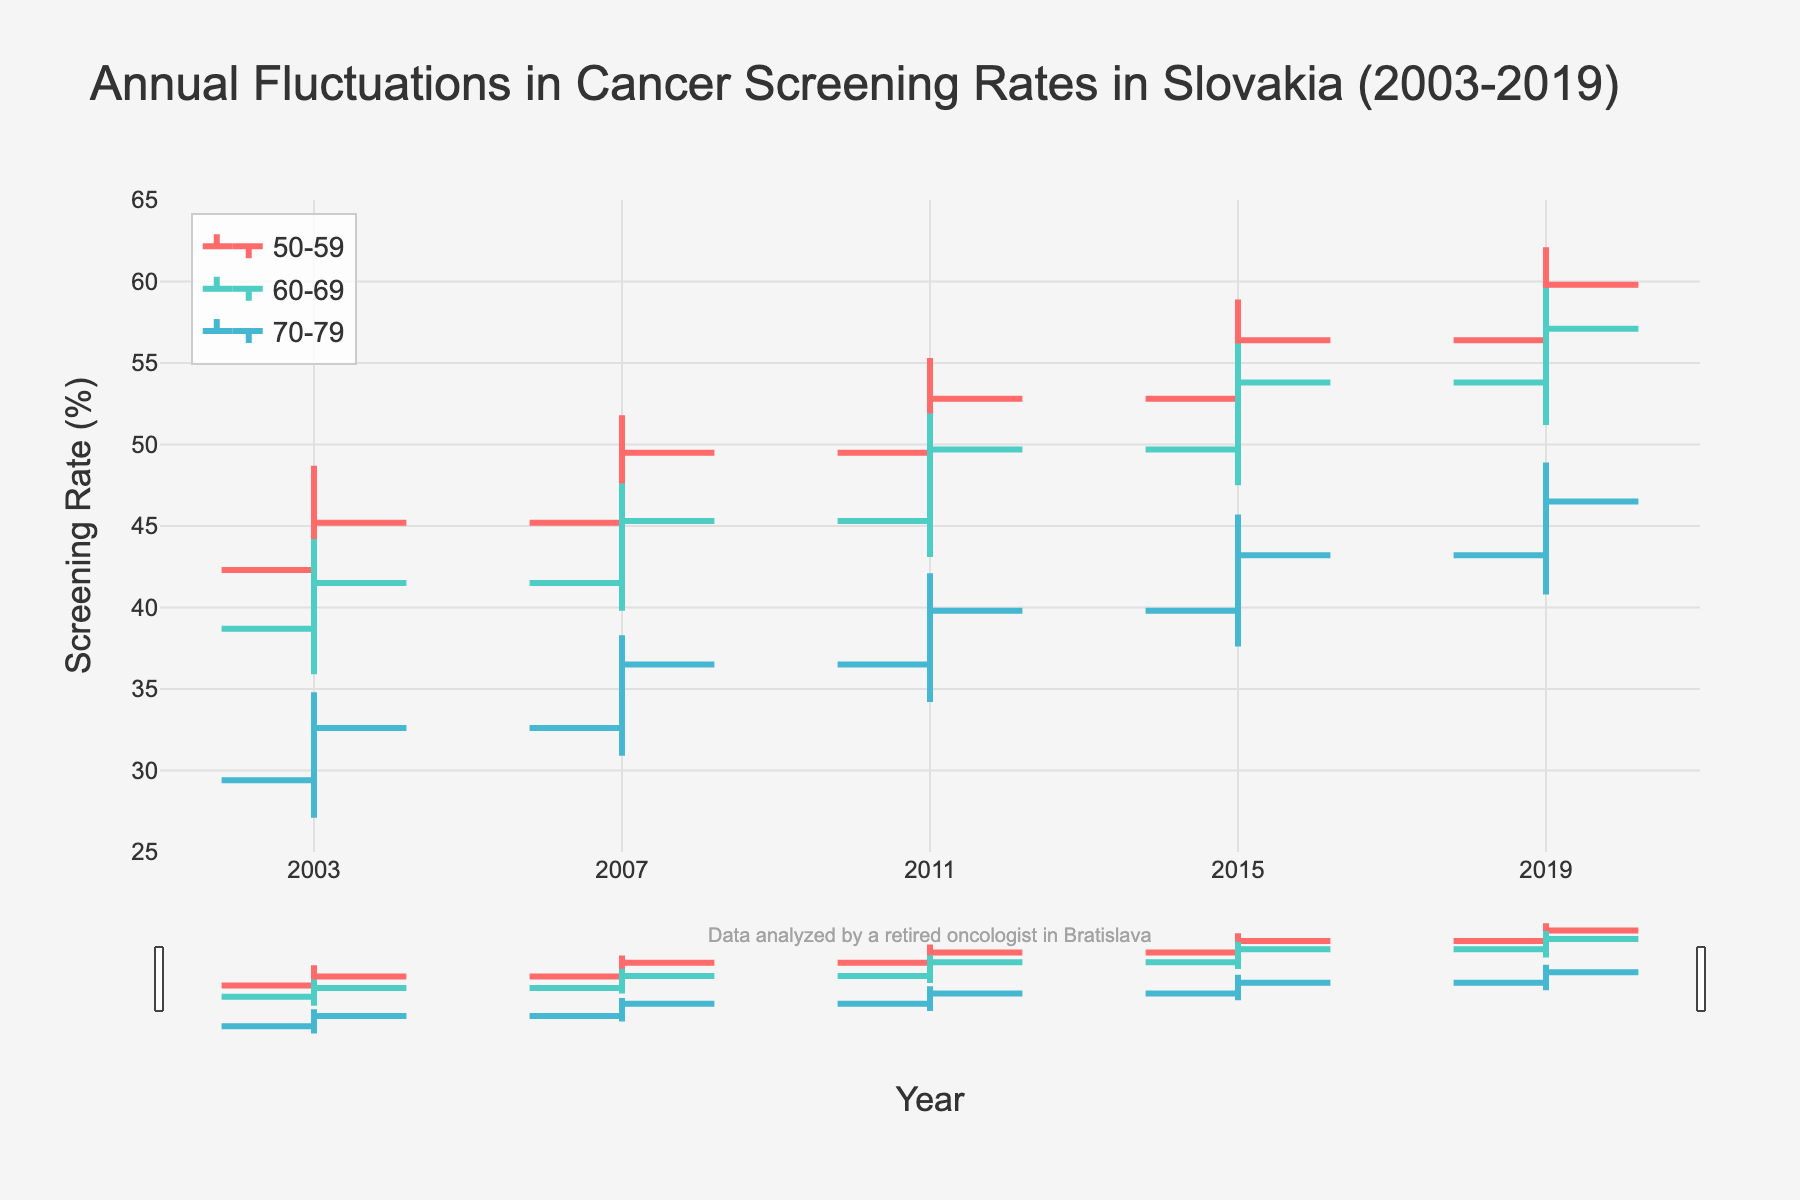What is the title of the figure? The title is located at the top of the chart and often describes what the chart portrays. Here, it reads "Annual Fluctuations in Cancer Screening Rates in Slovakia (2003-2019)."
Answer: Annual Fluctuations in Cancer Screening Rates in Slovakia (2003-2019) What is the y-axis title? The y-axis title describes what the vertical axis measures. In this chart, it indicates the percentage of screening rates.
Answer: Screening Rate (%) Which age group had the highest screening rate in 2019? To answer this, we need to identify the "High" value for all age groups in the year 2019 and pick the highest one. For 50-59, it is 62.1; for 60-69, it is 59.6; for 70-79, it is 48.9. The highest among these is 62.1 for the age group 50-59.
Answer: 50-59 What was the screening rate range for the age group 60-69 in 2003? To find the range, we need to determine the difference between "High" and "Low" values for the age group 60-69 in 2003. The "High" is 44.2 and the "Low" is 35.9. The range is 44.2 - 35.9 = 8.3.
Answer: 8.3 Between 2003 and 2019, how much did the closing screening rate increase for the age group 50-59? We subtract the closing rate in 2003 from the closing rate in 2019 for the age group 50-59. The closing rate in 2003 is 45.2, and in 2019 it is 59.8. The increase is 59.8 - 45.2 = 14.6.
Answer: 14.6 Which age group showed the smallest overall range in screening rates in 2015? We compare the ranges (High - Low) for each age group in 2015. For 50-59: 58.9 - 50.1 = 8.8; for 60-69: 56.2 - 47.5 = 8.7; for 70-79: 45.7 - 37.6 = 8.1. The smallest range is 8.1 for age group 70-79.
Answer: 70-79 Which age group had the most consistent screening rates from 2003 to 2019? Consistency can be judged by smaller ranges over time. Summing up the ranges for all years for each age group: 50-59: (48.7-39.1)+(51.8-43.6)+(55.3-47.2)+(58.9-50.1)+(62.1-54.7) = 9.6+8.2+8.1+8.8+7.4 = 42.1; 60-69: (44.2-35.9)+(47.6-39.8)+(51.9-43.1)+(56.2-47.5)+(59.6-51.2) = 8.3+7.8+8.8+8.7+8.4 = 42.0; 70-79: (34.8-27.1)+(38.3-30.9)+(42.1-34.2)+(45.7-37.6)+(48.9-40.8) = 7.7+7.4+7.9+8.1+8.1 = 39.2. The smallest total range is for age group 70-79.
Answer: 70-79 What is the average closing screening rate for the age group 70-79 over the given period? We sum the closing rates for the years 2003, 2007, 2011, 2015, and 2019, and then divide by the number of years. (32.6 + 36.5 + 39.8 + 43.2 + 46.5) / 5 = 198.6 / 5 = 39.72.
Answer: 39.72 In which period did the age group 50-59 have the largest increase in screening rates? We calculate the increase in the closing rate for each period for the age group 50-59: 2003-2007: 49.5-45.2=4.3; 2007-2011: 52.8-49.5=3.3; 2011-2015: 56.4-52.8=3.6; 2015-2019: 59.8-56.4=3.4. The largest increase is from 2003 to 2007 with a value of 4.3.
Answer: 2003-2007 How many age groups are visualized in the chart? By inspecting the data and the chart legend, we can see three distinct age groups are plotted: 50-59, 60-69, and 70-79.
Answer: 3 